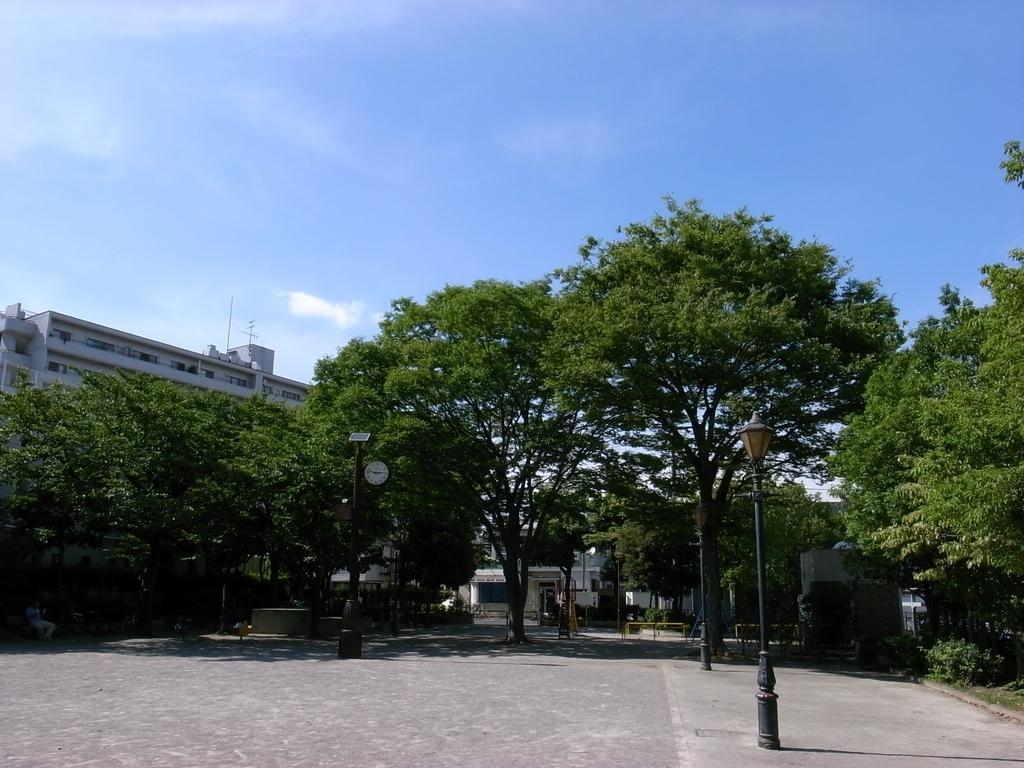In one or two sentences, can you explain what this image depicts? In this image I can see the road. To the side of the road there are light poles and the clock to the pole. In the back there are many trees and the building. I can also see the sky in the back. 